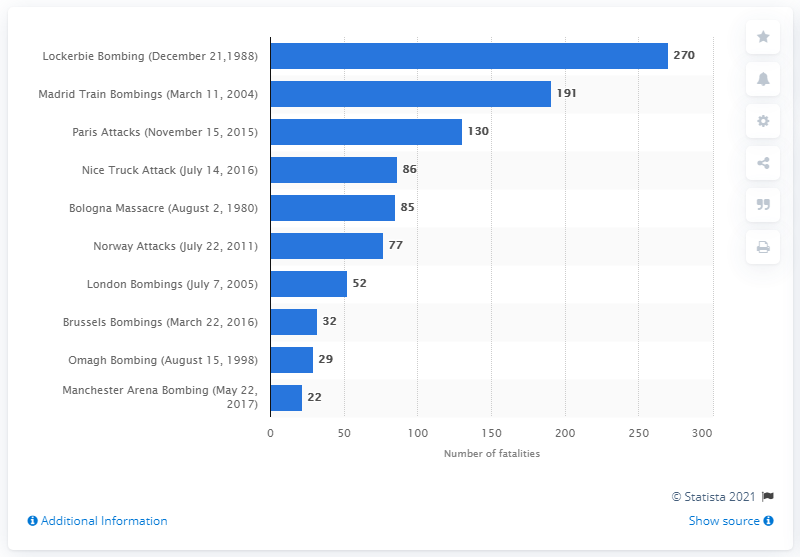Indicate a few pertinent items in this graphic. In the Lockerbie plane bombing, a total of 270 people lost their lives. In 2004, the Madrid train bombings resulted in the tragic loss of 191 lives. 